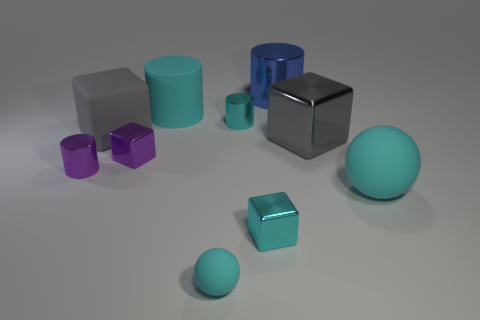Subtract all blocks. How many objects are left? 6 Subtract 0 red balls. How many objects are left? 10 Subtract all large yellow shiny things. Subtract all tiny objects. How many objects are left? 5 Add 2 large cyan rubber balls. How many large cyan rubber balls are left? 3 Add 2 tiny cyan shiny blocks. How many tiny cyan shiny blocks exist? 3 